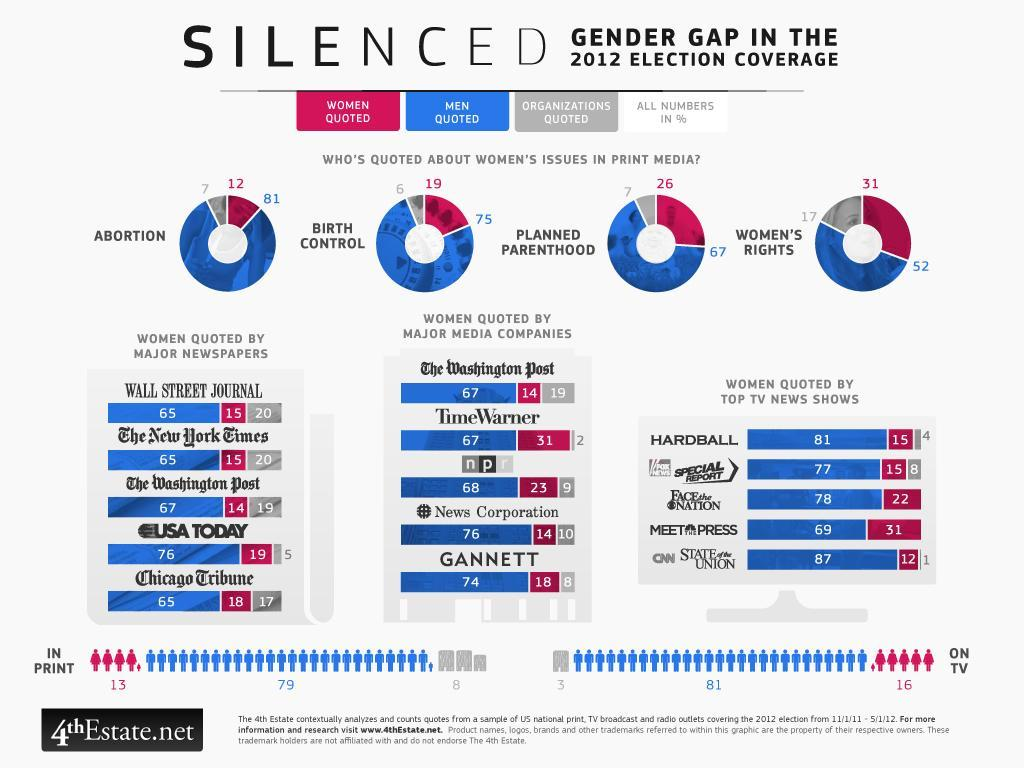Which print media gives the highest mentions of quotes by men ?
Answer the question with a short phrase. USA Today What is the number of mentions women find in TV, 8, 3, 16, or 81? 16 What were number of mentions women made about abortion in media, 31, 26,19, or 12? 12 Which TV news show has the highest mention of women in the 2012 election coverage? 31 What is the least number of times organizations are quoted by media outlets? 2 Who features least in print media, men, women, or organizations? organizations Who made the most number of mentions about women's rights in print media, men, women, or organizations? 52 